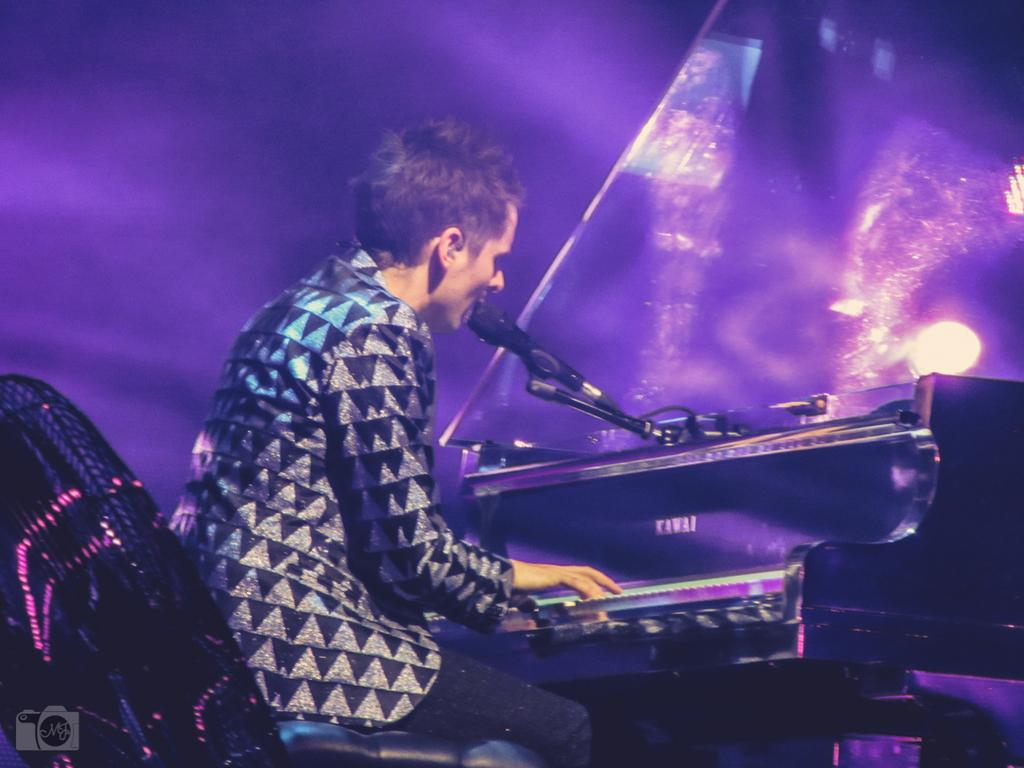Who is the main subject in the image? There is a man in the image. What is the man wearing? The man is wearing a black dress. What is the man doing in the image? The man is sitting. What is in front of the man? There is a piano and a microphone in front of the man. What color is the background of the image? The background of the image is violet. How many giants are present in the image? There are no giants present in the image; it features a man sitting in front of a piano and microphone. What type of chickens can be seen in the image? There are no chickens present in the image. 